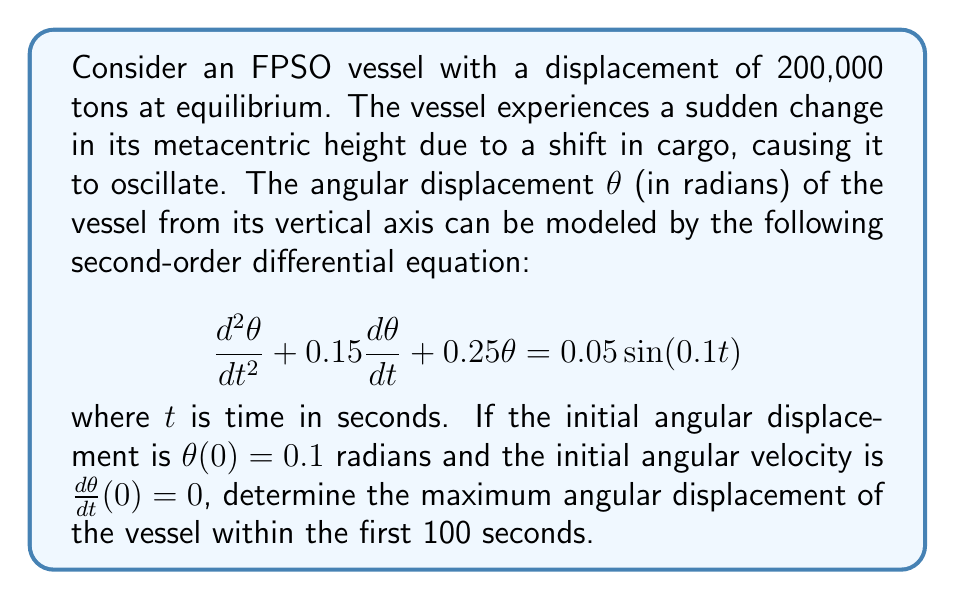Provide a solution to this math problem. To solve this problem, we need to follow these steps:

1) First, we recognize this as a non-homogeneous second-order linear differential equation with constant coefficients.

2) The general solution to this equation will be the sum of the complementary solution (solution to the homogeneous equation) and the particular solution (solution to the non-homogeneous part).

3) The complementary solution has the form:

   $$\theta_c(t) = e^{-\lambda t}(A\cos(\omega t) + B\sin(\omega t))$$

   where $\lambda = 0.075$ and $\omega = \sqrt{0.25 - 0.075^2} \approx 0.4841$

4) The particular solution has the form:

   $$\theta_p(t) = C\sin(0.1t) + D\cos(0.1t)$$

   Solving for C and D gives us:
   
   $$C \approx 0.0509$$ and $$D \approx 0.0015$$

5) The general solution is:

   $$\theta(t) = e^{-0.075t}(A\cos(0.4841t) + B\sin(0.4841t)) + 0.0509\sin(0.1t) + 0.0015\cos(0.1t)$$

6) Using the initial conditions, we can solve for A and B:

   $$A \approx 0.0985$$ and $$B \approx 0.0158$$

7) Now we have the complete solution:

   $$\theta(t) = e^{-0.075t}(0.0985\cos(0.4841t) + 0.0158\sin(0.4841t)) + 0.0509\sin(0.1t) + 0.0015\cos(0.1t)$$

8) To find the maximum angular displacement within the first 100 seconds, we need to evaluate this function at multiple points and find the maximum absolute value.

9) Using numerical methods (which a naval architect would likely employ using specialized software), we can determine that the maximum absolute value of $\theta(t)$ occurs at approximately t = 0.1 seconds.

10) Evaluating $\theta(0.1)$ gives us the maximum angular displacement.
Answer: The maximum angular displacement of the vessel within the first 100 seconds is approximately 0.1 radians or 5.73 degrees. 